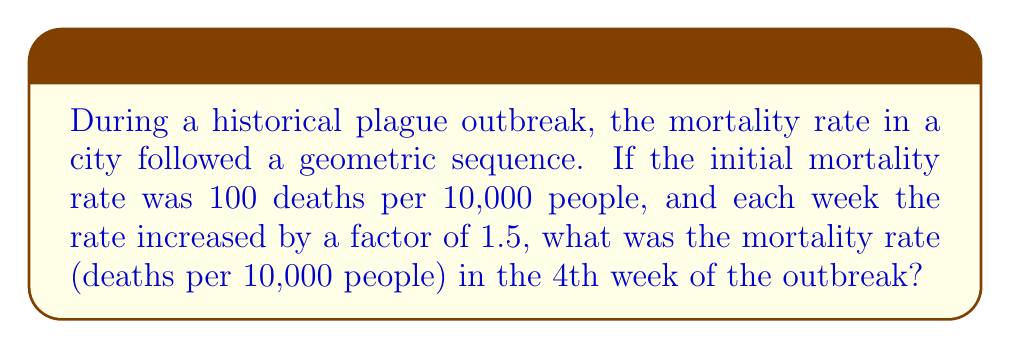What is the answer to this math problem? Let's approach this step-by-step:

1) In a geometric sequence, each term is a constant multiple of the previous term. In this case, the constant is 1.5.

2) Let's define our sequence:
   $a_1 = 100$ (initial rate)
   $r = 1.5$ (common ratio)

3) We need to find $a_4$ (4th week rate)

4) The general formula for the nth term of a geometric sequence is:
   $a_n = a_1 \cdot r^{n-1}$

5) Substituting our values:
   $a_4 = 100 \cdot 1.5^{4-1}$
   $a_4 = 100 \cdot 1.5^3$

6) Calculate:
   $a_4 = 100 \cdot 3.375 = 337.5$

Therefore, in the 4th week, the mortality rate was 337.5 deaths per 10,000 people.
Answer: 337.5 deaths per 10,000 people 